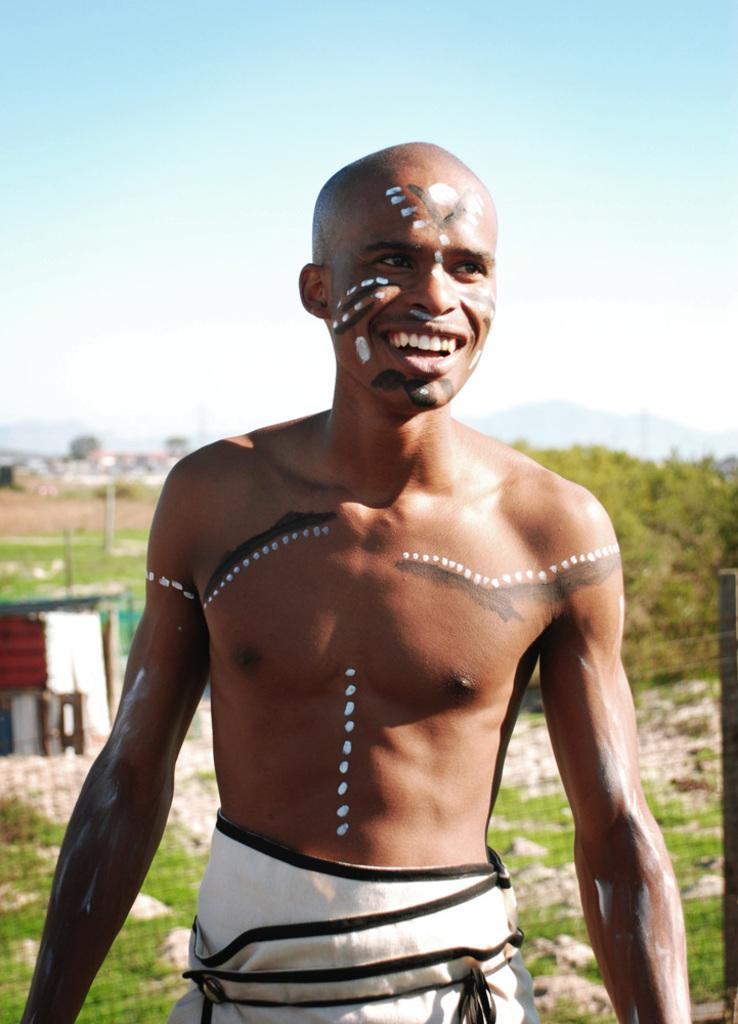Who is present in the image? There is a man standing in the image. What can be seen in the background of the image? There are trees in the background of the image. What type of engine is powering the bird in the image? There is no bird or engine present in the image; it only features a man standing and trees in the background. 